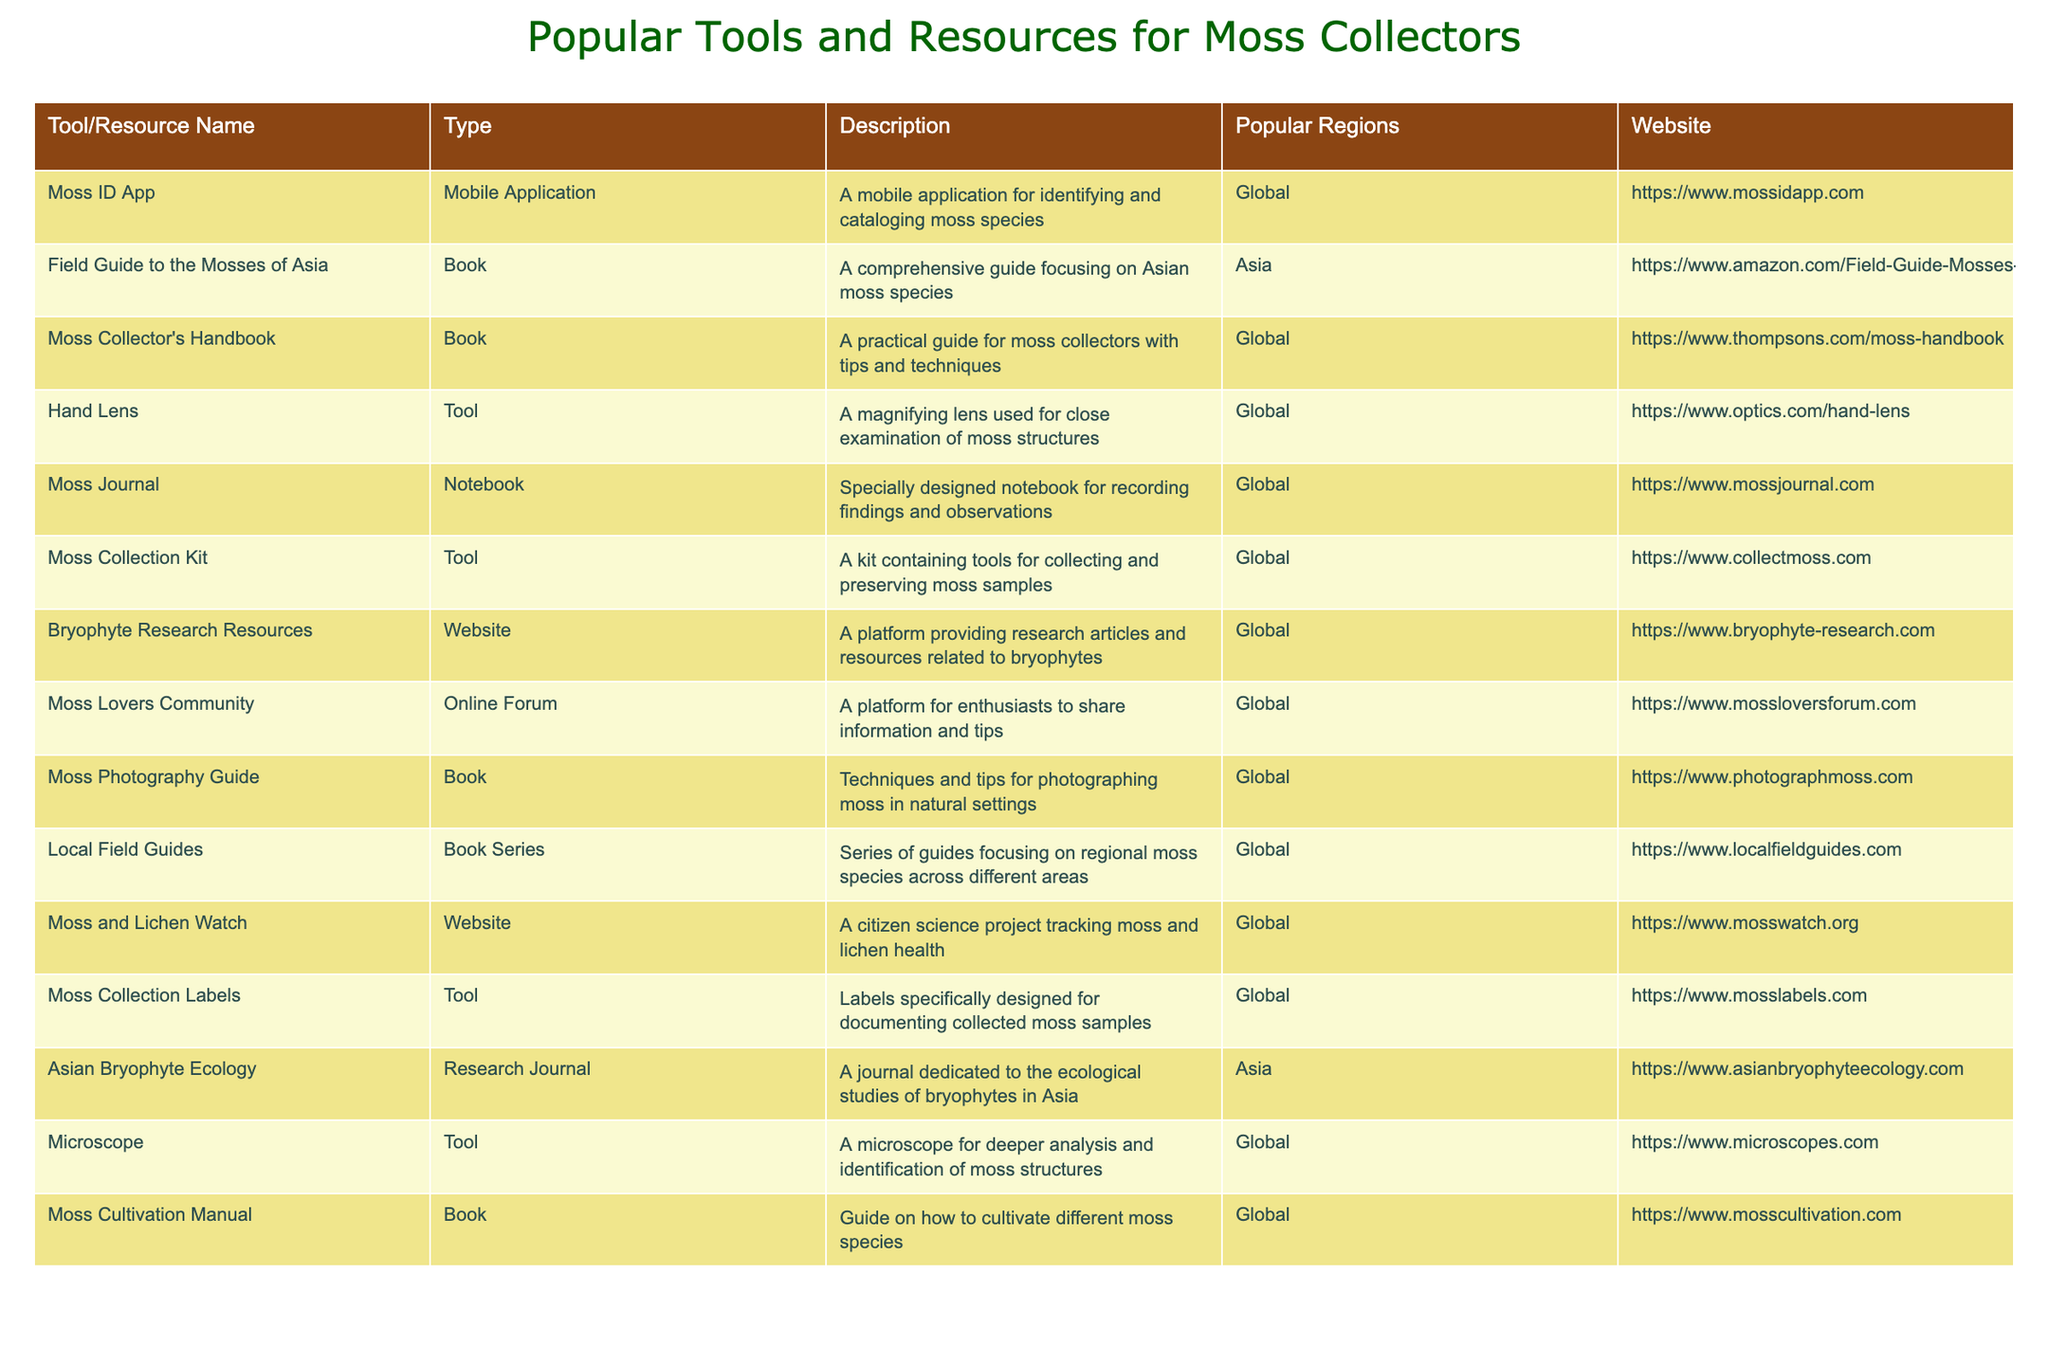What is the website for the Moss ID App? The website is explicitly listed under the "Website" column for the "Moss ID App" row in the table.
Answer: https://www.mossidapp.com Which tools are specifically designed for documenting collected moss samples? The table lists "Moss Collection Labels" under the "Tool" category, indicating it is designed for documenting collected samples.
Answer: Moss Collection Labels How many resources are dedicated to Asian moss species? By examining the "Popular Regions" column, there are two resources specifically for Asian moss species: "Field Guide to the Mosses of Asia" and "Asian Bryophyte Ecology".
Answer: 2 Is there a resource that provides a platform for moss enthusiasts to share information? The "Moss Lovers Community" under the "Online Forum" category serves as a platform for enthusiasts to interact and share.
Answer: Yes What tool functions similarly to a microscope for analyzing moss structures? The "Hand Lens" is mentioned as a tool for close examination, which serves a similar analytical purpose as a microscope.
Answer: Hand Lens Which resources are categorized under books? To find the resources categorized as books, we look at the "Type" column, which shows that titles like "Field Guide to the Mosses of Asia," "Moss Collector's Handbook," "Moss Photography Guide," and others fall under this category. There are six book resources.
Answer: 6 How many different types of resources are listed in the table? By counting distinct entries in the "Type" column, there are three different types: Mobile Application, Book, Tool, Notebook, Website, and Research Journal, totaling six types of resources.
Answer: 6 Identify the tool used for deeper analysis of moss structures. The "Microscope" is explicitly listed in the "Tool" section of the table, indicating its purpose for deeper analysis.
Answer: Microscope Which resource is focused on cultivation techniques for moss species? The resource "Moss Cultivation Manual" is specifically dedicated to cultivation techniques.
Answer: Moss Cultivation Manual What is the common feature of resources that have "Asia" in their Popular Regions? Both resources focused on Asian moss species include guidance or research related to bryophytes in Asia, indicated in their descriptions.
Answer: Guidance or research on bryophytes in Asia 